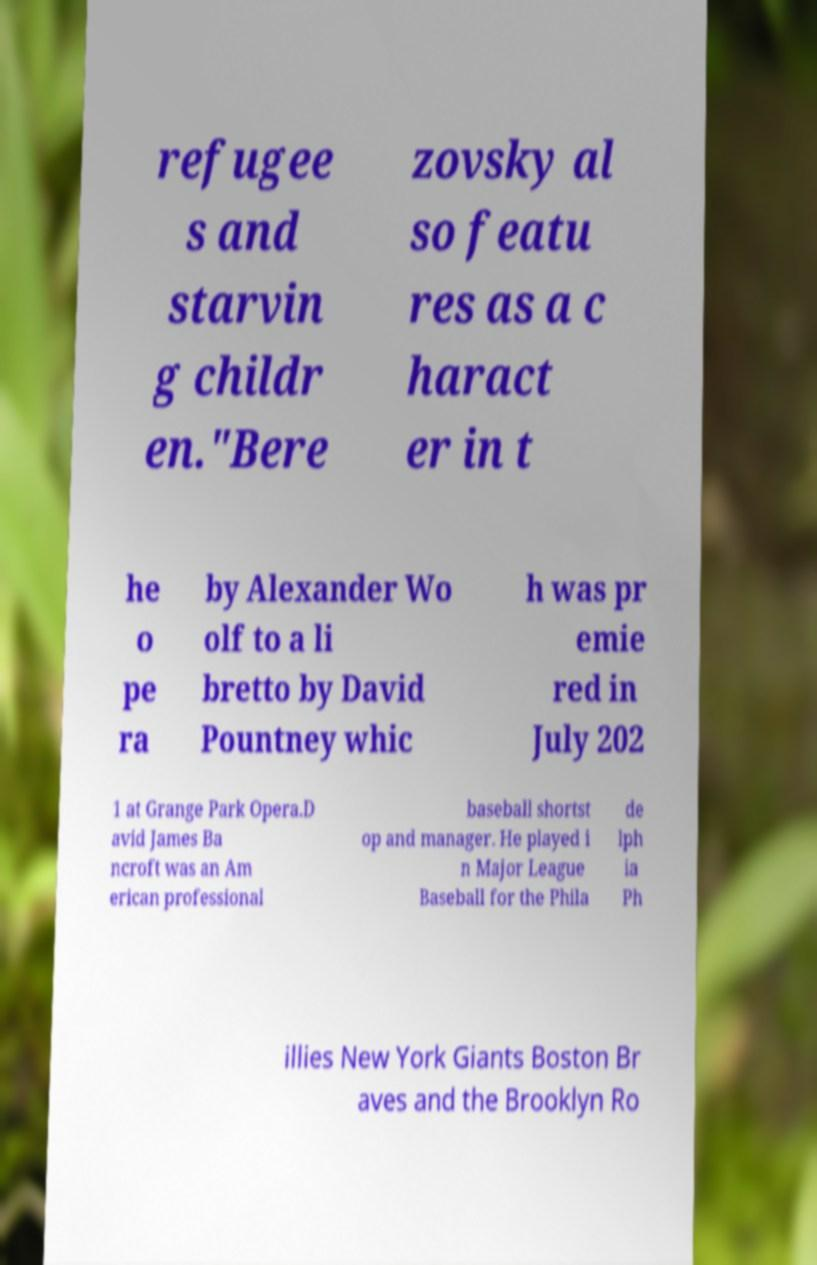I need the written content from this picture converted into text. Can you do that? refugee s and starvin g childr en."Bere zovsky al so featu res as a c haract er in t he o pe ra by Alexander Wo olf to a li bretto by David Pountney whic h was pr emie red in July 202 1 at Grange Park Opera.D avid James Ba ncroft was an Am erican professional baseball shortst op and manager. He played i n Major League Baseball for the Phila de lph ia Ph illies New York Giants Boston Br aves and the Brooklyn Ro 